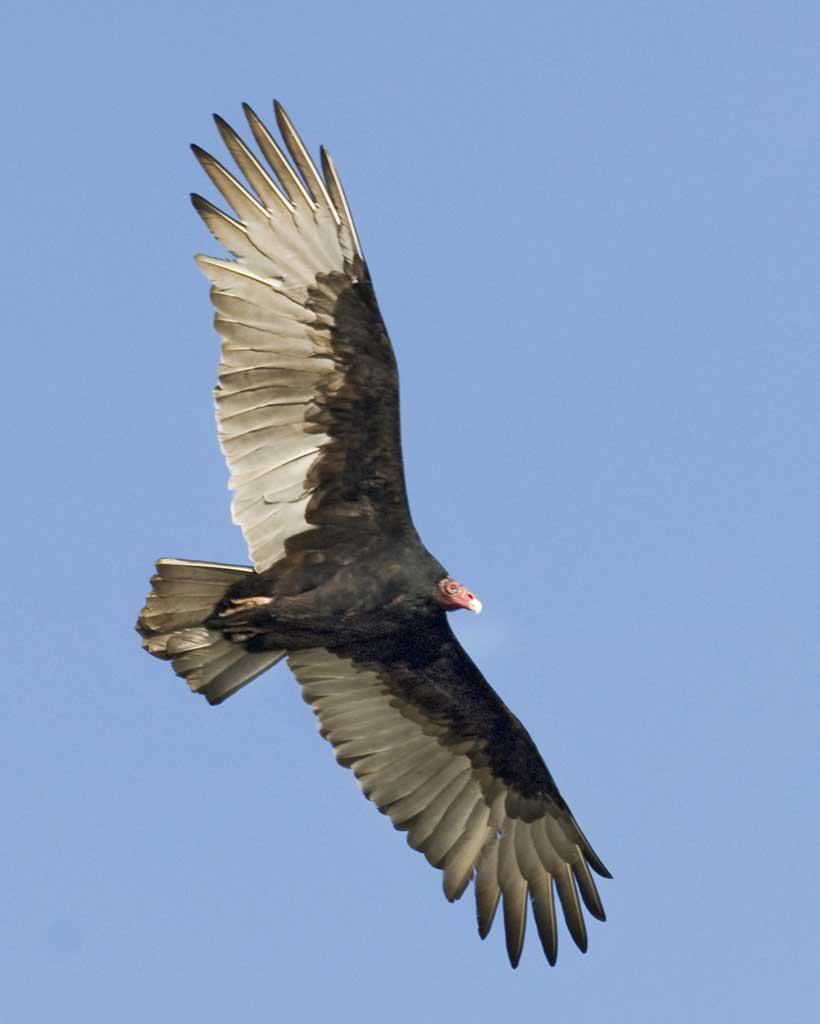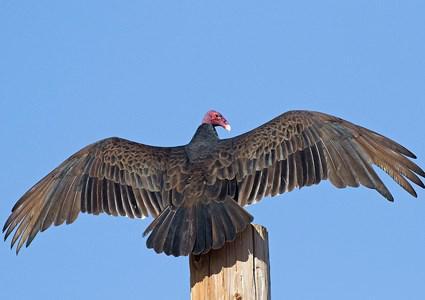The first image is the image on the left, the second image is the image on the right. Considering the images on both sides, is "Two large birds have their wings extended, one in the air and one sitting." valid? Answer yes or no. Yes. The first image is the image on the left, the second image is the image on the right. Considering the images on both sides, is "An image shows one vulture perched on something, with its wings spread horizontally." valid? Answer yes or no. Yes. 